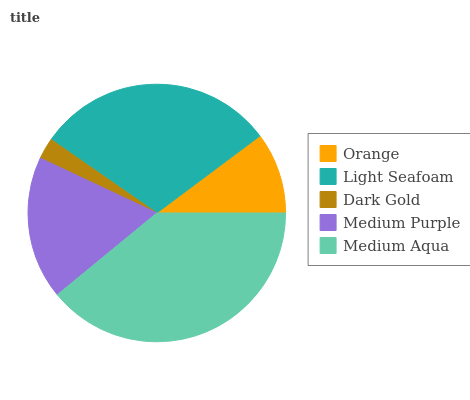Is Dark Gold the minimum?
Answer yes or no. Yes. Is Medium Aqua the maximum?
Answer yes or no. Yes. Is Light Seafoam the minimum?
Answer yes or no. No. Is Light Seafoam the maximum?
Answer yes or no. No. Is Light Seafoam greater than Orange?
Answer yes or no. Yes. Is Orange less than Light Seafoam?
Answer yes or no. Yes. Is Orange greater than Light Seafoam?
Answer yes or no. No. Is Light Seafoam less than Orange?
Answer yes or no. No. Is Medium Purple the high median?
Answer yes or no. Yes. Is Medium Purple the low median?
Answer yes or no. Yes. Is Orange the high median?
Answer yes or no. No. Is Orange the low median?
Answer yes or no. No. 